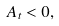Convert formula to latex. <formula><loc_0><loc_0><loc_500><loc_500>A _ { t } < 0 ,</formula> 